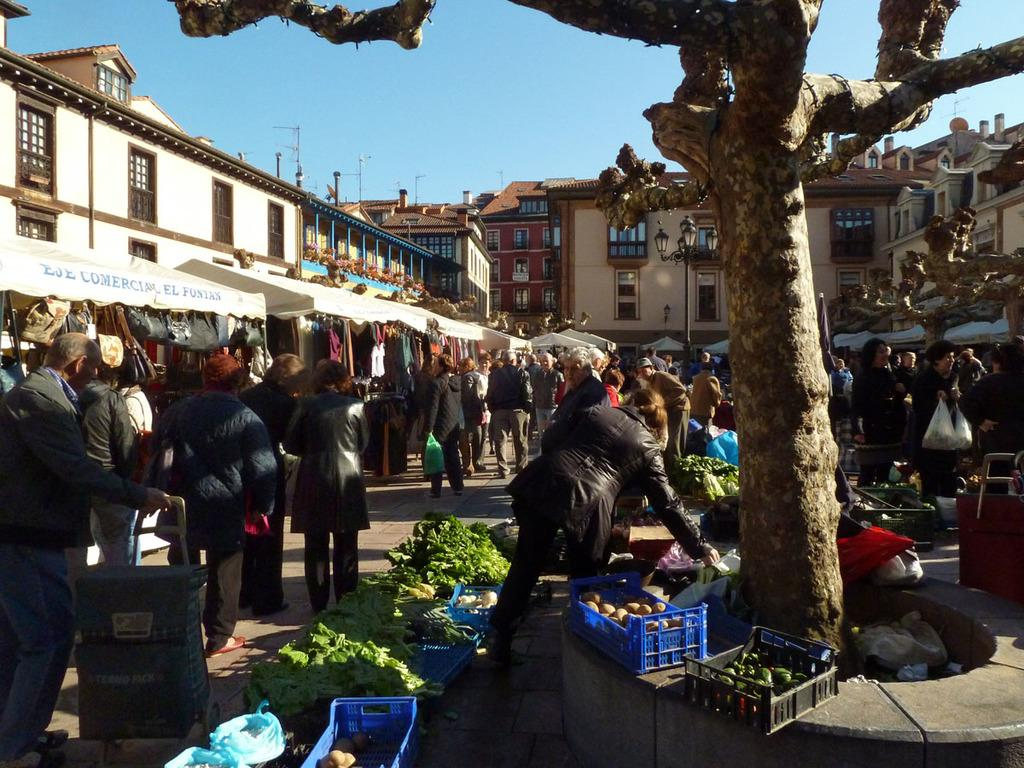What type of structures can be seen in the image? There are buildings in the image. What else is present in the image besides the buildings? There is a large crowd of people, various vegetables, electric poles, a tree, and the sky visible in the image. What time of day is it in the image, and where is the dad? The provided facts do not mention a dad or the time of day, so we cannot answer these questions based on the image. 